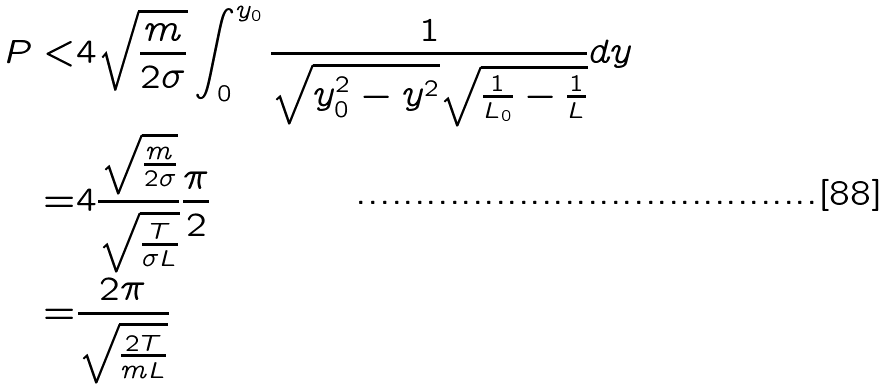Convert formula to latex. <formula><loc_0><loc_0><loc_500><loc_500>P < & 4 \sqrt { \frac { m } { 2 \sigma } } \int _ { 0 } ^ { y _ { 0 } } \frac { 1 } { \sqrt { y _ { 0 } ^ { 2 } - y ^ { 2 } } \sqrt { \frac { 1 } { L _ { 0 } } - \frac { 1 } { L } } } d y \\ = & 4 \frac { \sqrt { \frac { m } { 2 \sigma } } } { \sqrt { \frac { T } { \sigma L } } } \frac { \pi } { 2 } \\ = & \frac { 2 \pi } { \sqrt { \frac { 2 T } { m L } } }</formula> 